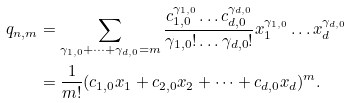<formula> <loc_0><loc_0><loc_500><loc_500>q _ { n , m } & = \sum _ { \gamma _ { 1 , 0 } + \dots + \gamma _ { d , 0 } = m } \frac { c _ { 1 , 0 } ^ { \gamma _ { 1 , 0 } } \dots c _ { d , 0 } ^ { \gamma _ { d , 0 } } } { \gamma _ { 1 , 0 } ! \dots \gamma _ { d , 0 } ! } x _ { 1 } ^ { \gamma _ { 1 , 0 } } \dots x _ { d } ^ { \gamma _ { d , 0 } } \\ & = \frac { 1 } { m ! } ( c _ { 1 , 0 } x _ { 1 } + c _ { 2 , 0 } x _ { 2 } + \dots + c _ { d , 0 } x _ { d } ) ^ { m } .</formula> 